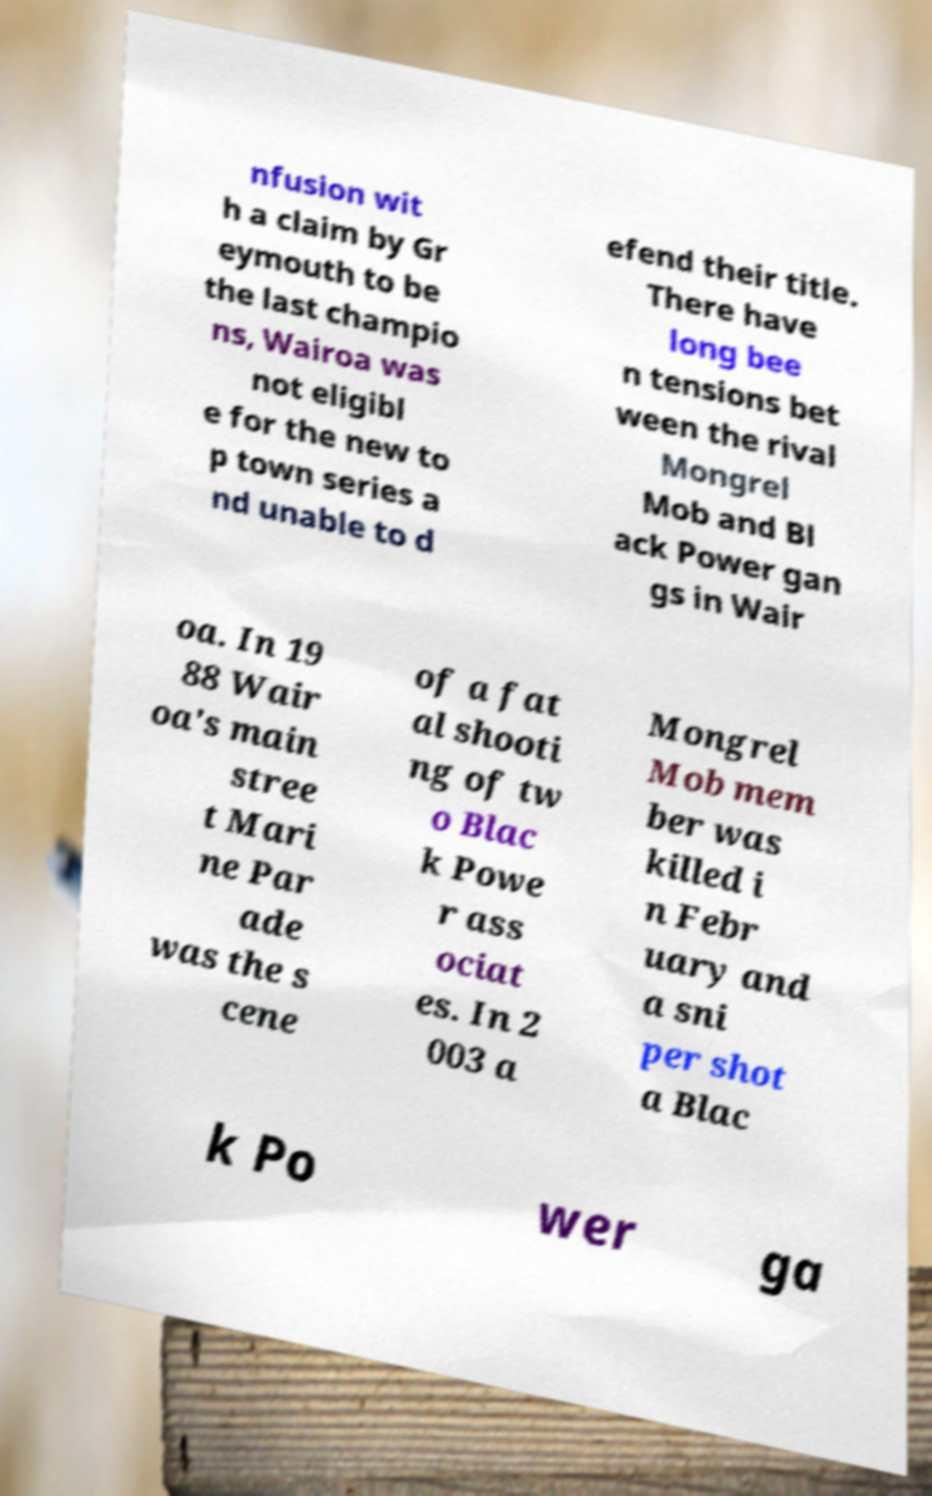I need the written content from this picture converted into text. Can you do that? nfusion wit h a claim by Gr eymouth to be the last champio ns, Wairoa was not eligibl e for the new to p town series a nd unable to d efend their title. There have long bee n tensions bet ween the rival Mongrel Mob and Bl ack Power gan gs in Wair oa. In 19 88 Wair oa's main stree t Mari ne Par ade was the s cene of a fat al shooti ng of tw o Blac k Powe r ass ociat es. In 2 003 a Mongrel Mob mem ber was killed i n Febr uary and a sni per shot a Blac k Po wer ga 